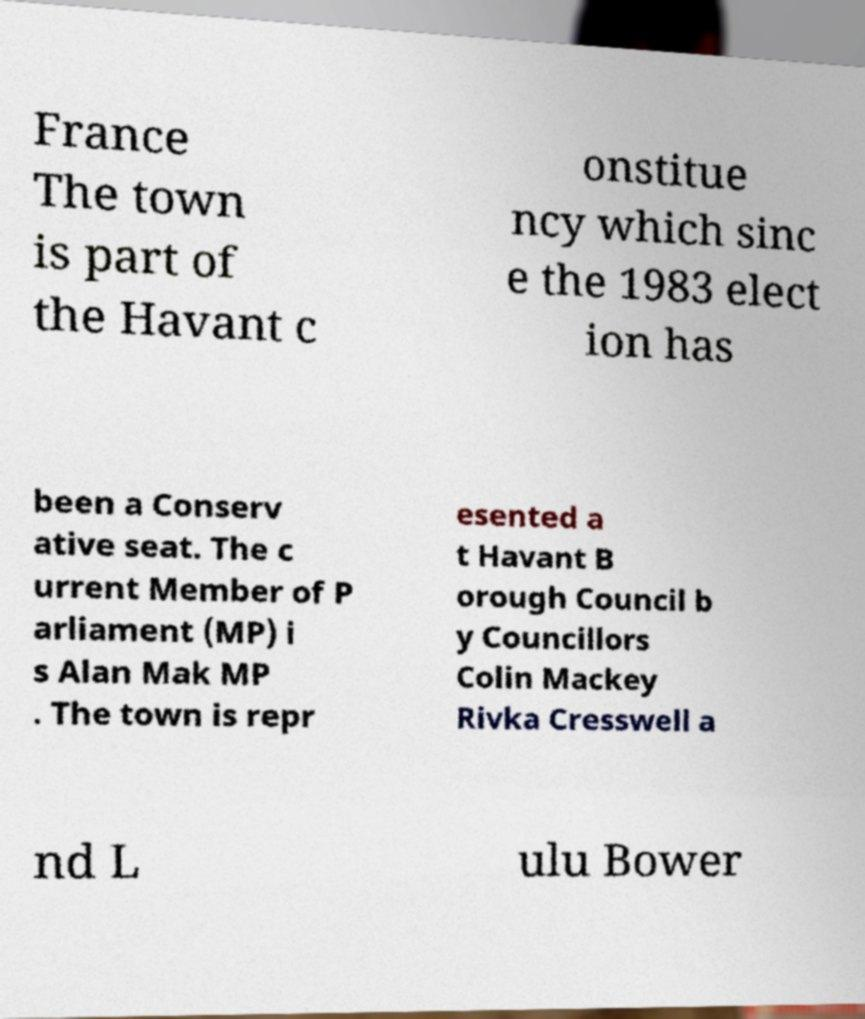What messages or text are displayed in this image? I need them in a readable, typed format. France The town is part of the Havant c onstitue ncy which sinc e the 1983 elect ion has been a Conserv ative seat. The c urrent Member of P arliament (MP) i s Alan Mak MP . The town is repr esented a t Havant B orough Council b y Councillors Colin Mackey Rivka Cresswell a nd L ulu Bower 